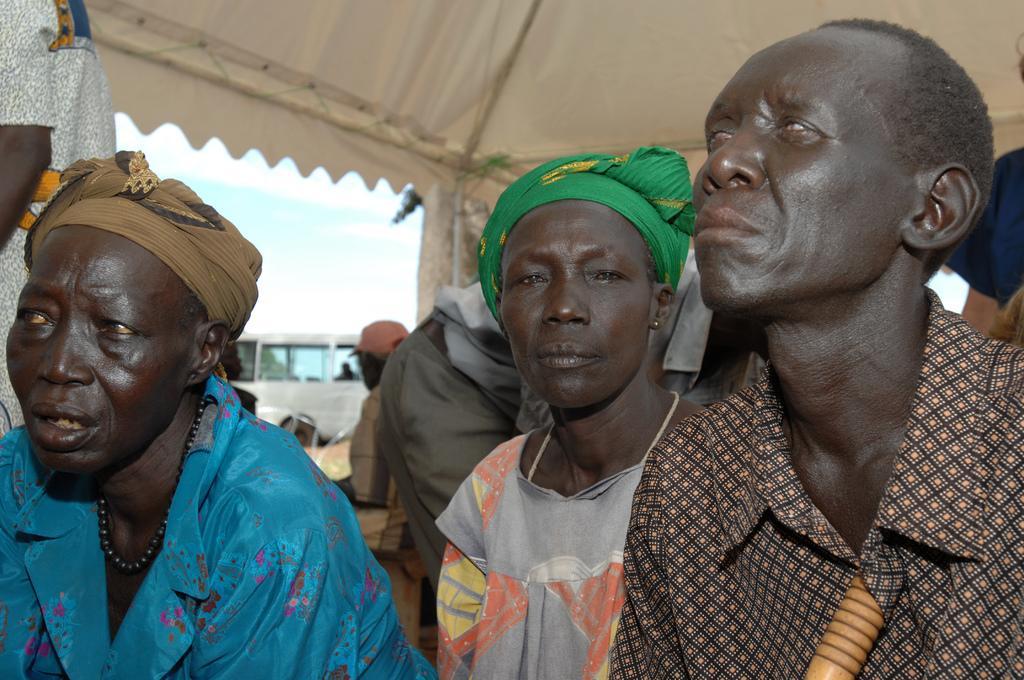Please provide a concise description of this image. In this image I can see the group of people. These people are wearing the different color dresses. These people are under the shed. To the side of the people I can see vehicle and in the back there is a sky. 